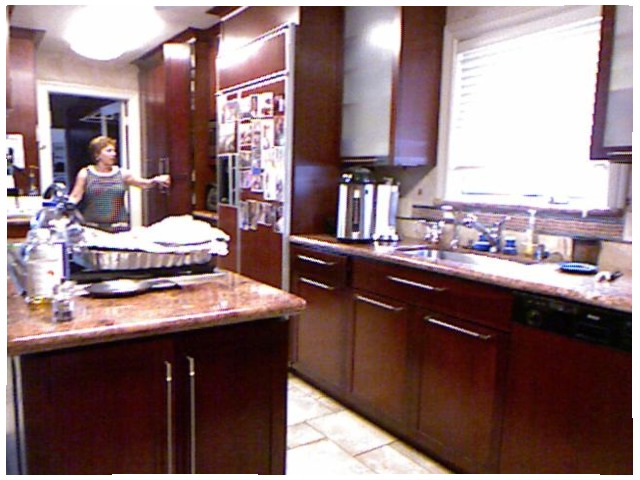<image>
Is the sink next to the window? Yes. The sink is positioned adjacent to the window, located nearby in the same general area. 